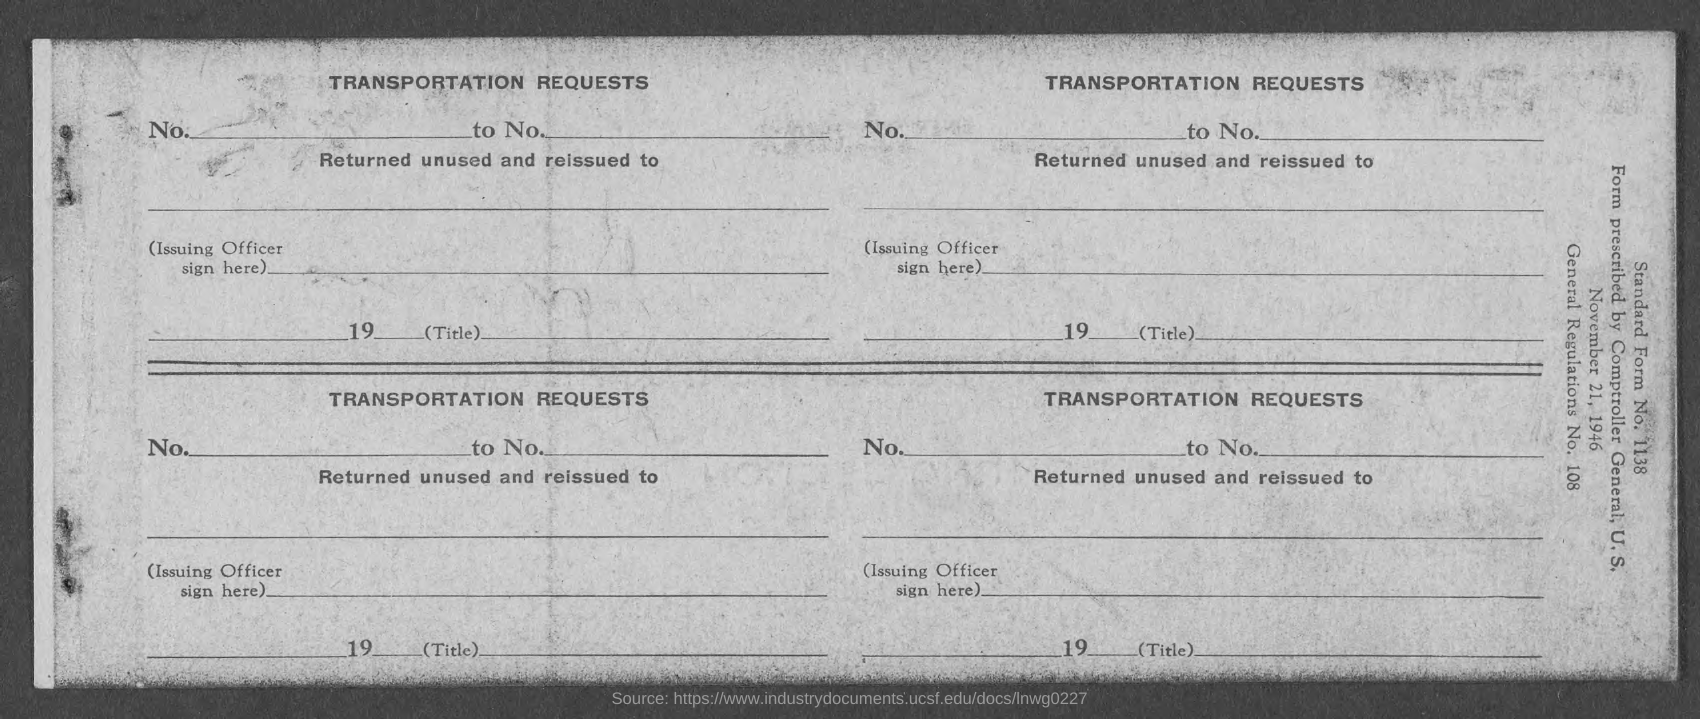What type of document is this?
Provide a short and direct response. Transportation request. 